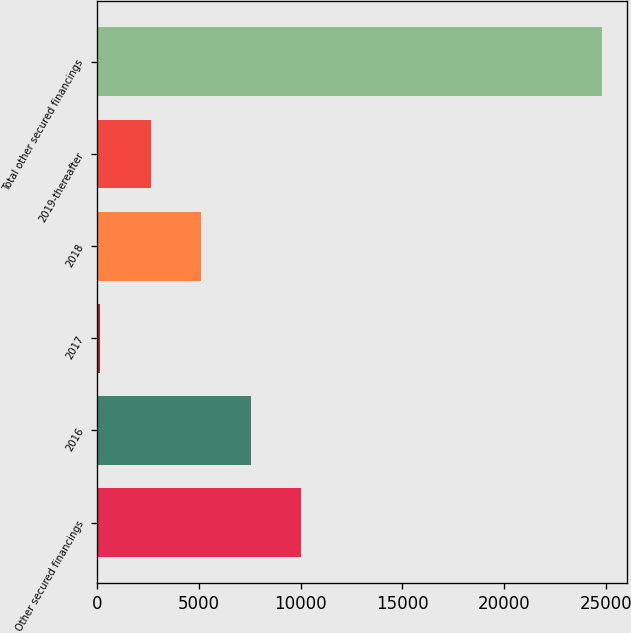Convert chart. <chart><loc_0><loc_0><loc_500><loc_500><bar_chart><fcel>Other secured financings<fcel>2016<fcel>2017<fcel>2018<fcel>2019-thereafter<fcel>Total other secured financings<nl><fcel>10022.8<fcel>7557.6<fcel>162<fcel>5092.4<fcel>2627.2<fcel>24814<nl></chart> 